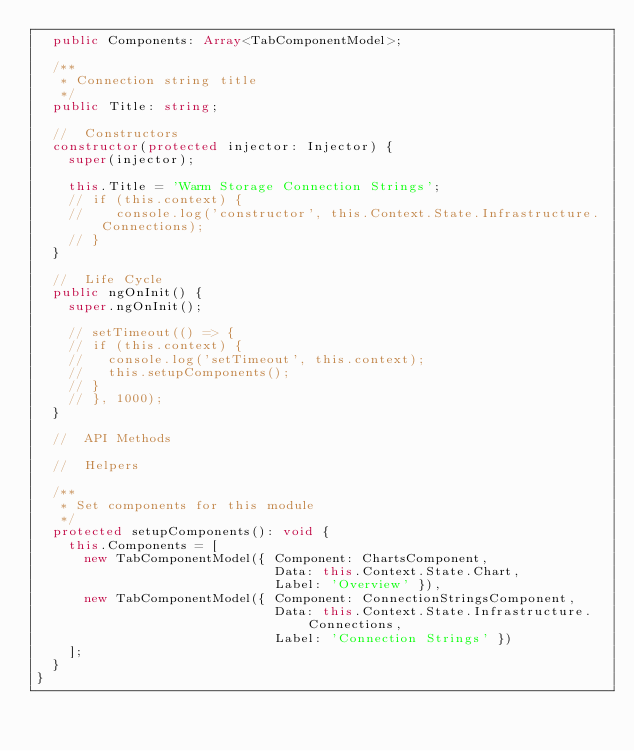Convert code to text. <code><loc_0><loc_0><loc_500><loc_500><_TypeScript_>  public Components: Array<TabComponentModel>;

  /**
   * Connection string title
   */
  public Title: string;

  //  Constructors
  constructor(protected injector: Injector) {
    super(injector);

    this.Title = 'Warm Storage Connection Strings';
    // if (this.context) {
    //    console.log('constructor', this.Context.State.Infrastructure.Connections);
    // }
  }

  //  Life Cycle
  public ngOnInit() {
    super.ngOnInit();

    // setTimeout(() => {
    // if (this.context) {
    //   console.log('setTimeout', this.context);
    //   this.setupComponents();
    // }
    // }, 1000);
  }

  //  API Methods

  //  Helpers

  /**
   * Set components for this module
   */
  protected setupComponents(): void {
    this.Components = [
      new TabComponentModel({ Component: ChartsComponent,
                              Data: this.Context.State.Chart,
                              Label: 'Overview' }),
      new TabComponentModel({ Component: ConnectionStringsComponent,
                              Data: this.Context.State.Infrastructure.Connections,
                              Label: 'Connection Strings' })
    ];
  }
}
</code> 